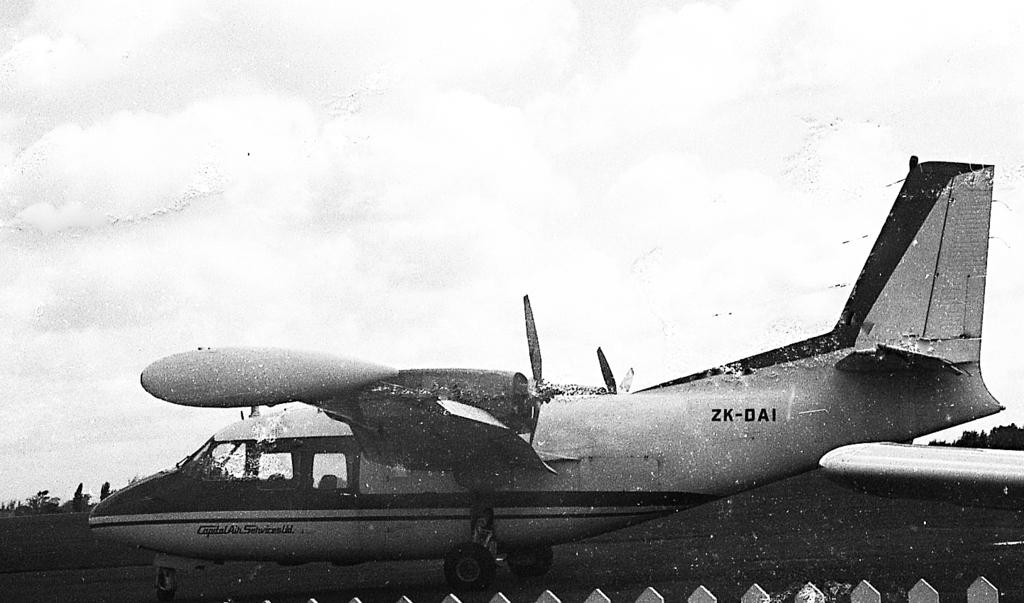<image>
Summarize the visual content of the image. A twin engine airplane with the letters ZK-DAI on the side. 